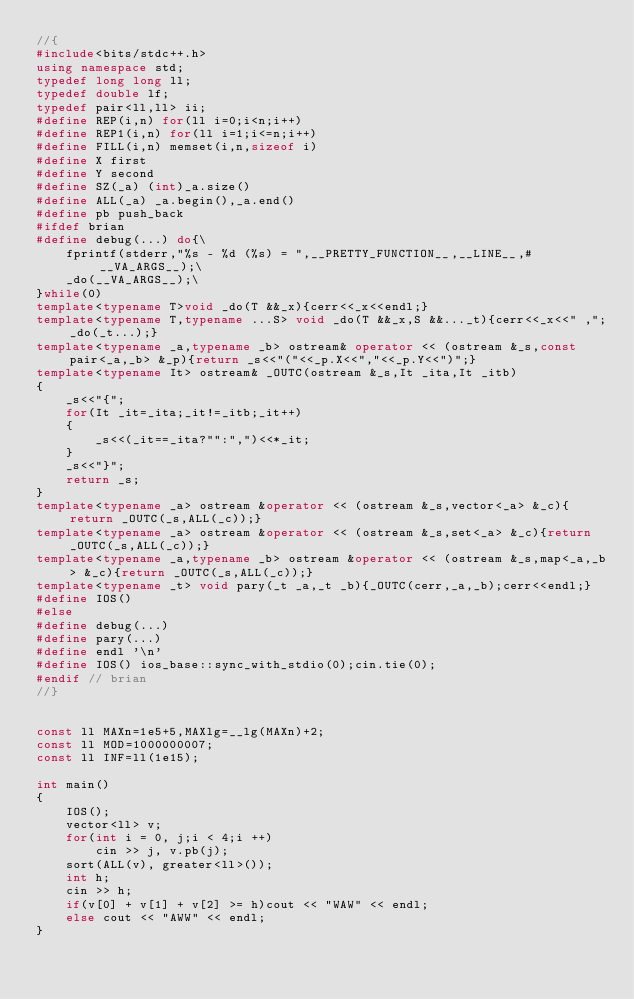<code> <loc_0><loc_0><loc_500><loc_500><_C++_>//{
#include<bits/stdc++.h>
using namespace std;
typedef long long ll;
typedef double lf;
typedef pair<ll,ll> ii;
#define REP(i,n) for(ll i=0;i<n;i++)
#define REP1(i,n) for(ll i=1;i<=n;i++)
#define FILL(i,n) memset(i,n,sizeof i)
#define X first
#define Y second
#define SZ(_a) (int)_a.size()
#define ALL(_a) _a.begin(),_a.end()
#define pb push_back
#ifdef brian
#define debug(...) do{\
    fprintf(stderr,"%s - %d (%s) = ",__PRETTY_FUNCTION__,__LINE__,#__VA_ARGS__);\
    _do(__VA_ARGS__);\
}while(0)
template<typename T>void _do(T &&_x){cerr<<_x<<endl;}
template<typename T,typename ...S> void _do(T &&_x,S &&..._t){cerr<<_x<<" ,";_do(_t...);}
template<typename _a,typename _b> ostream& operator << (ostream &_s,const pair<_a,_b> &_p){return _s<<"("<<_p.X<<","<<_p.Y<<")";}
template<typename It> ostream& _OUTC(ostream &_s,It _ita,It _itb)
{
    _s<<"{";
    for(It _it=_ita;_it!=_itb;_it++)
    {
        _s<<(_it==_ita?"":",")<<*_it;
    }
    _s<<"}";
    return _s;
}
template<typename _a> ostream &operator << (ostream &_s,vector<_a> &_c){return _OUTC(_s,ALL(_c));}
template<typename _a> ostream &operator << (ostream &_s,set<_a> &_c){return _OUTC(_s,ALL(_c));}
template<typename _a,typename _b> ostream &operator << (ostream &_s,map<_a,_b> &_c){return _OUTC(_s,ALL(_c));}
template<typename _t> void pary(_t _a,_t _b){_OUTC(cerr,_a,_b);cerr<<endl;}
#define IOS()
#else
#define debug(...)
#define pary(...)
#define endl '\n'
#define IOS() ios_base::sync_with_stdio(0);cin.tie(0);
#endif // brian
//}


const ll MAXn=1e5+5,MAXlg=__lg(MAXn)+2;
const ll MOD=1000000007;
const ll INF=ll(1e15);

int main()
{
    IOS();
    vector<ll> v;
    for(int i = 0, j;i < 4;i ++)
        cin >> j, v.pb(j);
    sort(ALL(v), greater<ll>());
    int h;
    cin >> h;
    if(v[0] + v[1] + v[2] >= h)cout << "WAW" << endl;
    else cout << "AWW" << endl;
}
</code> 